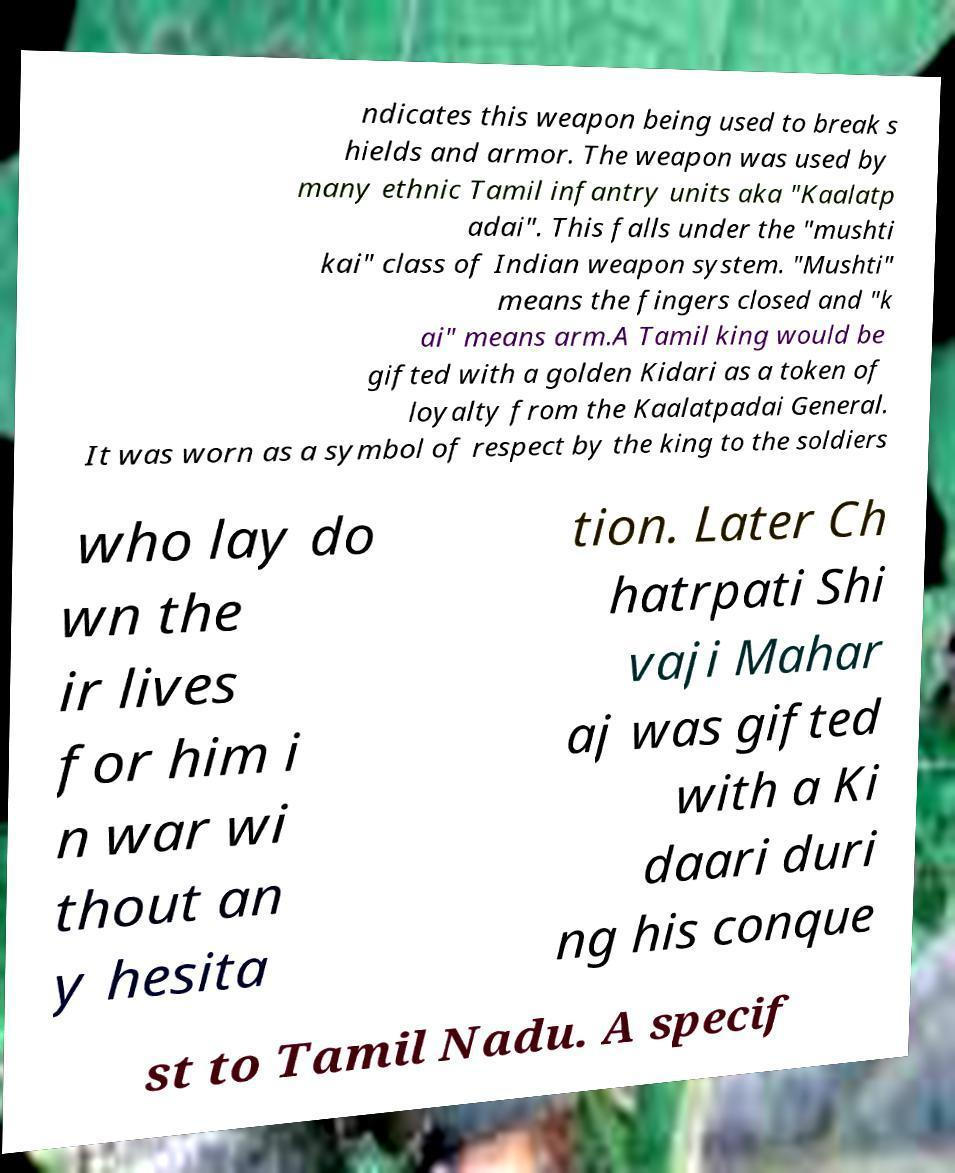For documentation purposes, I need the text within this image transcribed. Could you provide that? ndicates this weapon being used to break s hields and armor. The weapon was used by many ethnic Tamil infantry units aka "Kaalatp adai". This falls under the "mushti kai" class of Indian weapon system. "Mushti" means the fingers closed and "k ai" means arm.A Tamil king would be gifted with a golden Kidari as a token of loyalty from the Kaalatpadai General. It was worn as a symbol of respect by the king to the soldiers who lay do wn the ir lives for him i n war wi thout an y hesita tion. Later Ch hatrpati Shi vaji Mahar aj was gifted with a Ki daari duri ng his conque st to Tamil Nadu. A specif 